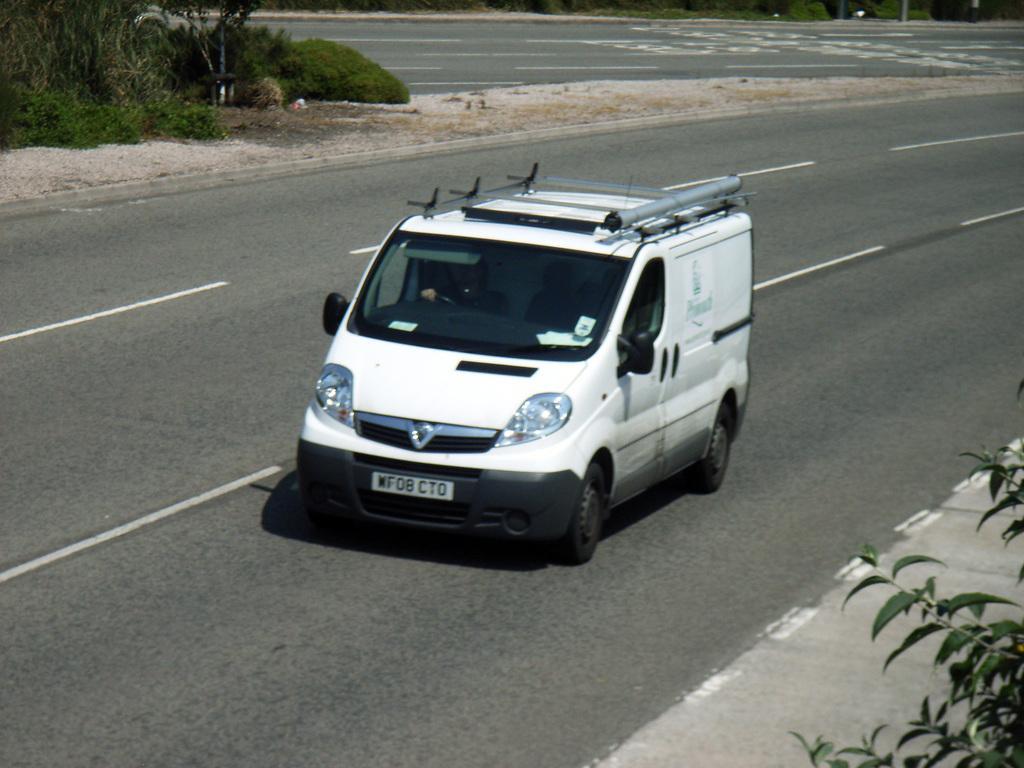Can you describe this image briefly? In this image we can see a person is driving a vehicle. There is a two way road in the image. There are many plants in the image. 